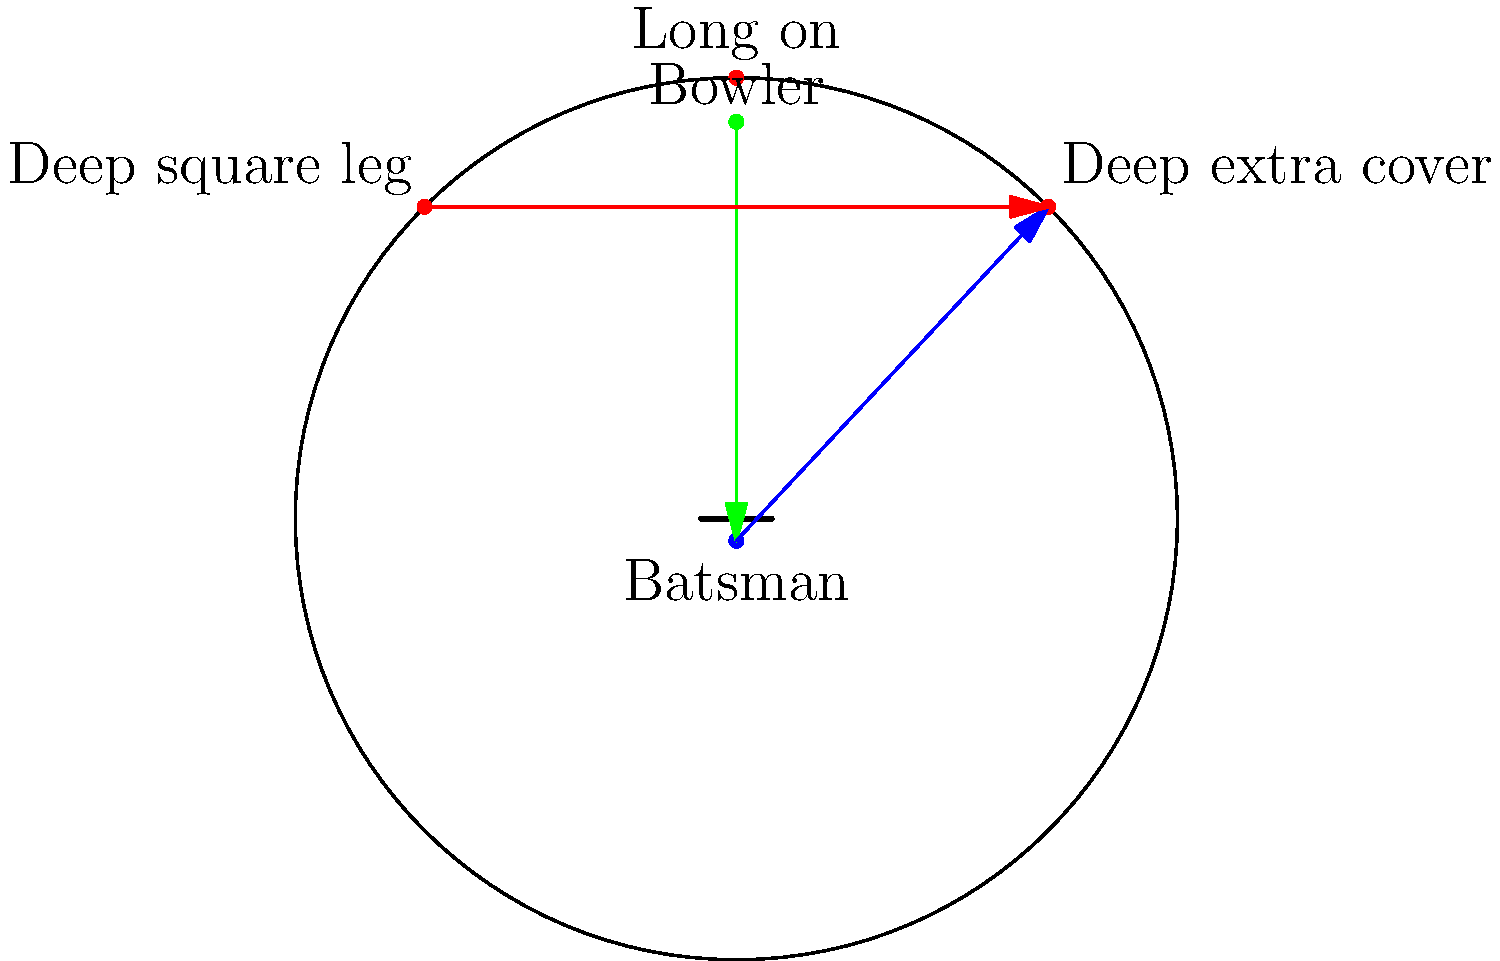In a cricket match, a fast bowler is delivering to a right-handed batsman who tends to play aggressive shots through the off-side. Given the field setup shown, which fielding position should adjust their vector of movement to optimize the chance of a catch, and in which direction? To answer this question, we need to analyze the given field setup and the likely trajectory of the ball based on the batsman's tendencies:

1. The bowler is positioned at the top of the diagram, delivering to the batsman at the bottom.
2. We're told the batsman is right-handed and tends to play aggressive shots through the off-side.
3. For a right-handed batsman, the off-side is to the right of the pitch from the bowler's perspective.
4. Given this information, the most likely area for the ball to be hit is towards the deep extra cover region.
5. The deep extra cover fielder is positioned at the top-right of the diagram.
6. To optimize the chance of a catch, this fielder should move in anticipation of the shot.
7. The ideal movement would be to adjust slightly inwards, moving along a vector from their current position towards the batsman.
8. This adjustment would allow them to cover more ground quickly if the ball is hit in their direction, increasing the chances of taking a catch.

Therefore, the deep extra cover fielder should adjust their vector of movement inwards, towards the batsman, to optimize their chance of taking a catch.
Answer: Deep extra cover, moving inwards 